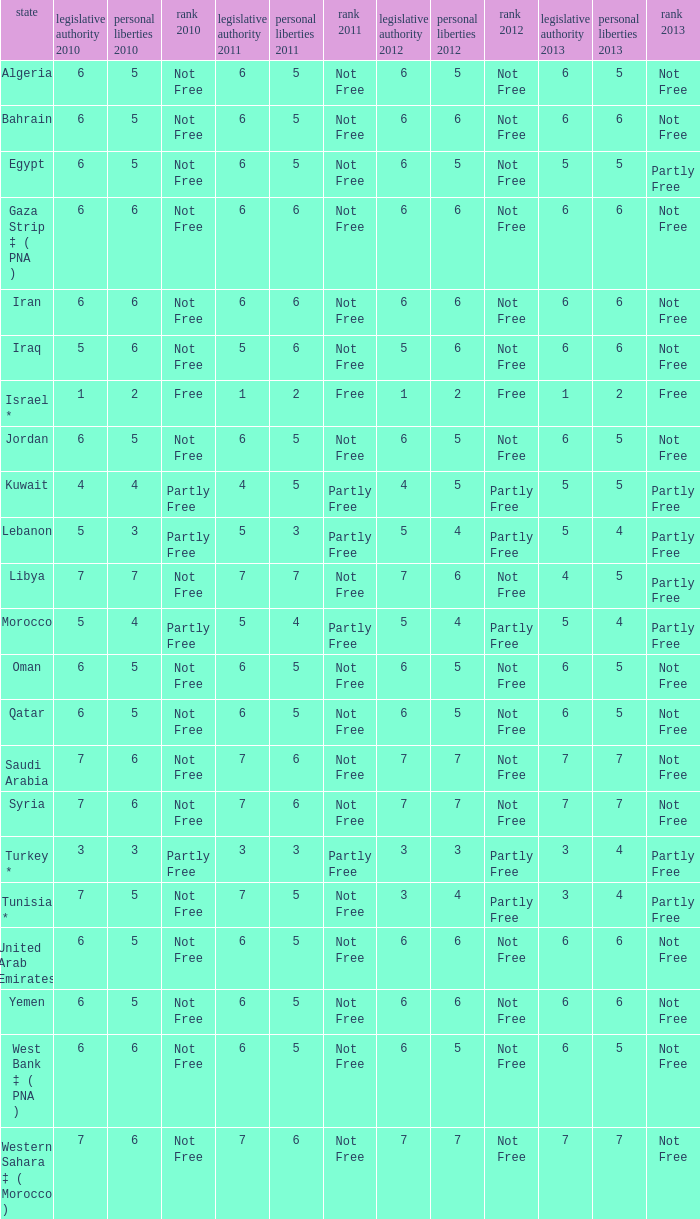What is the total number of civil liberties 2011 values having 2010 political rights values under 3 and 2011 political rights values under 1? 0.0. 